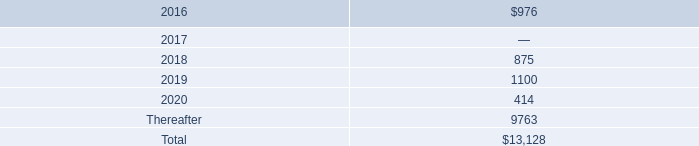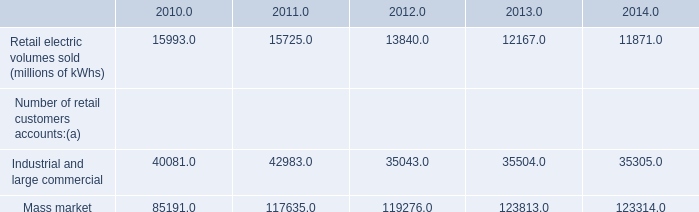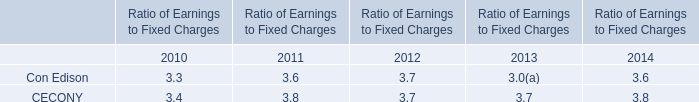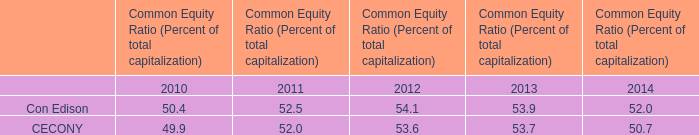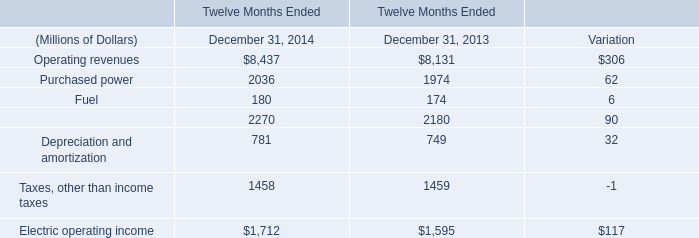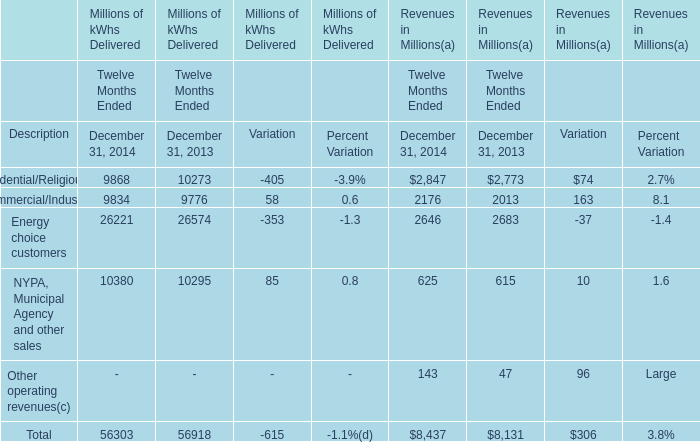what is the highest total amount of Commercial/Industrial? (in Million) 
Answer: 9834. 